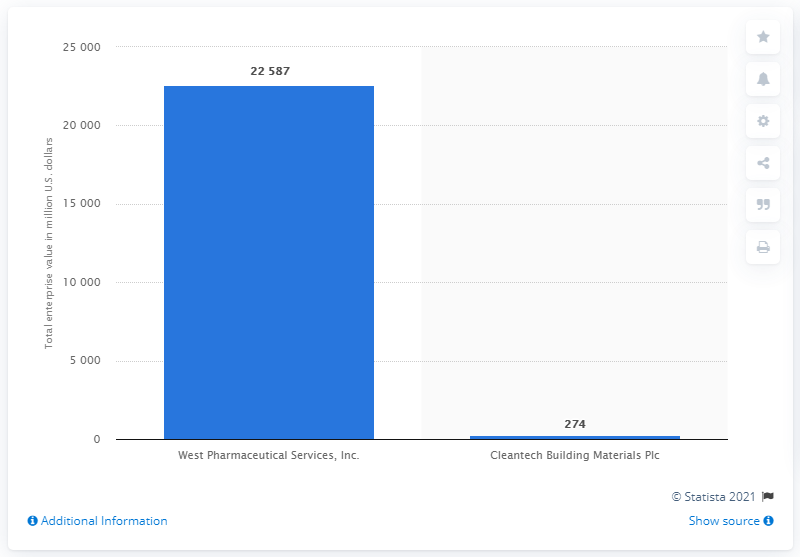List a handful of essential elements in this visual. As of January 31, 2021, West Pharmaceutical Services Inc.'s total enterprise value was approximately 22,587. 